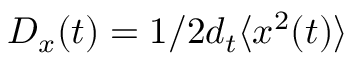<formula> <loc_0><loc_0><loc_500><loc_500>D _ { x } ( t ) = 1 / 2 d _ { t } \langle x ^ { 2 } ( t ) \rangle</formula> 